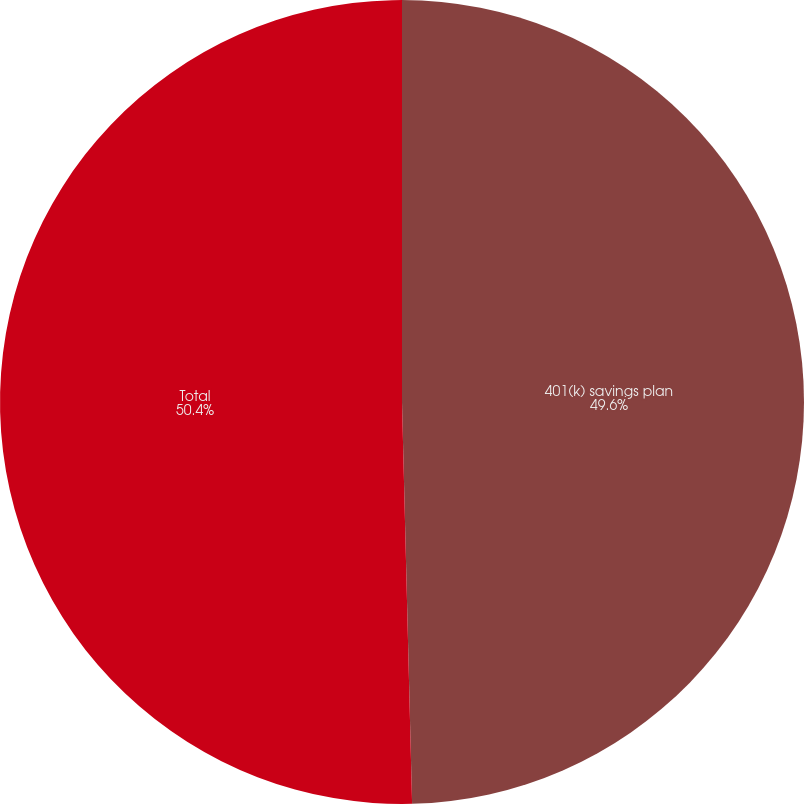<chart> <loc_0><loc_0><loc_500><loc_500><pie_chart><fcel>401(k) savings plan<fcel>Total<nl><fcel>49.6%<fcel>50.4%<nl></chart> 